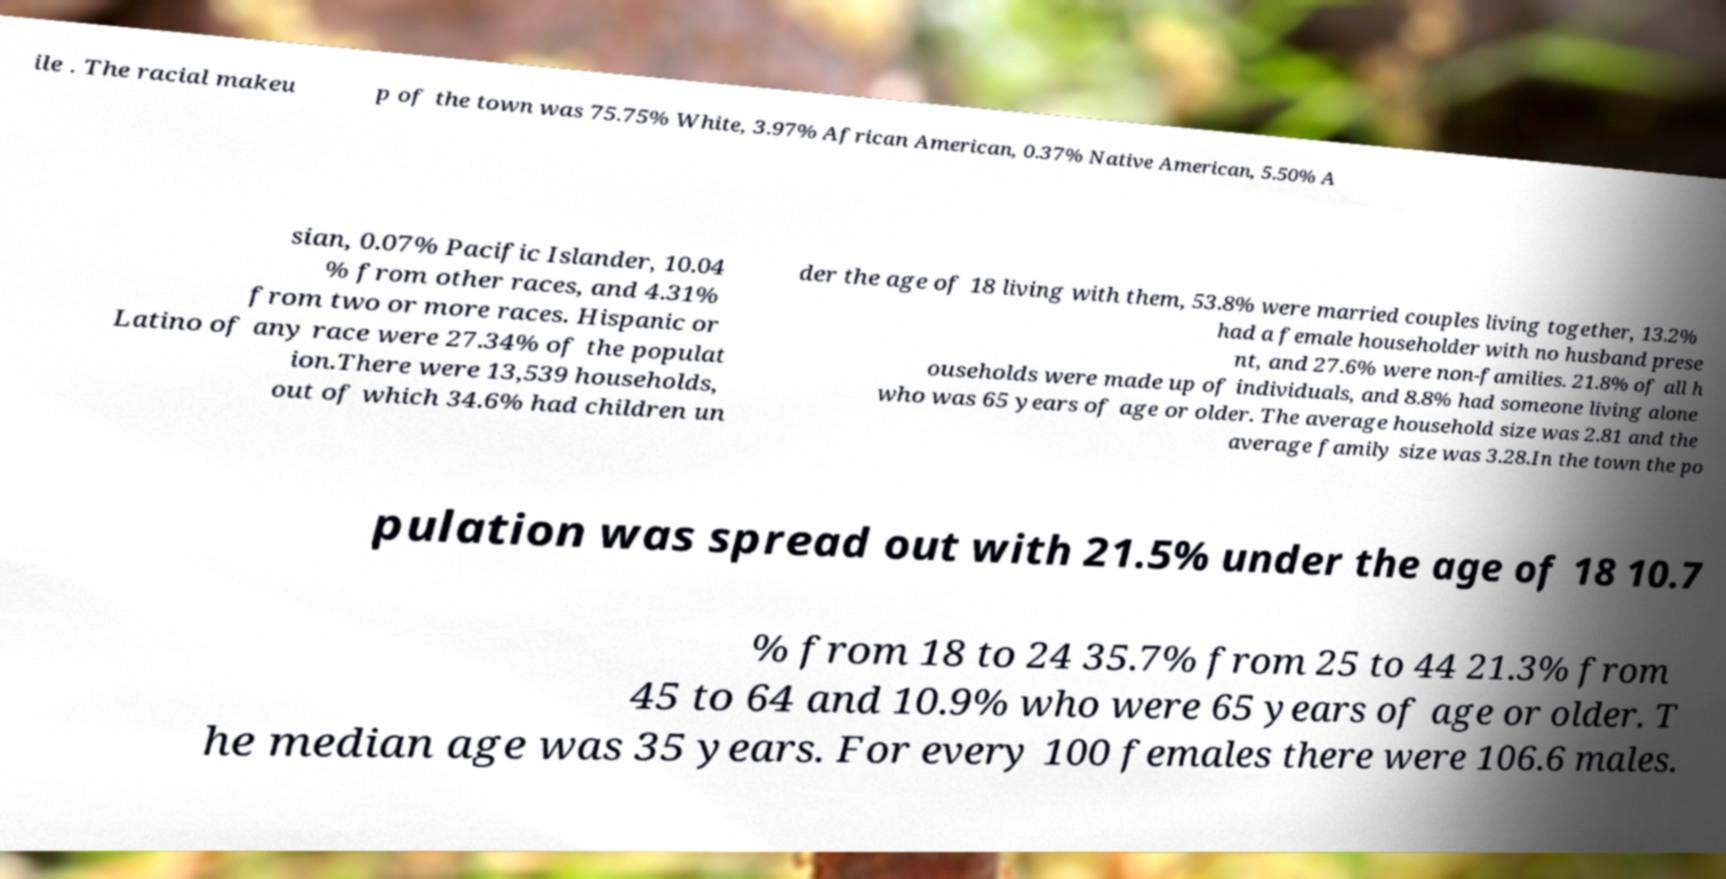I need the written content from this picture converted into text. Can you do that? ile . The racial makeu p of the town was 75.75% White, 3.97% African American, 0.37% Native American, 5.50% A sian, 0.07% Pacific Islander, 10.04 % from other races, and 4.31% from two or more races. Hispanic or Latino of any race were 27.34% of the populat ion.There were 13,539 households, out of which 34.6% had children un der the age of 18 living with them, 53.8% were married couples living together, 13.2% had a female householder with no husband prese nt, and 27.6% were non-families. 21.8% of all h ouseholds were made up of individuals, and 8.8% had someone living alone who was 65 years of age or older. The average household size was 2.81 and the average family size was 3.28.In the town the po pulation was spread out with 21.5% under the age of 18 10.7 % from 18 to 24 35.7% from 25 to 44 21.3% from 45 to 64 and 10.9% who were 65 years of age or older. T he median age was 35 years. For every 100 females there were 106.6 males. 